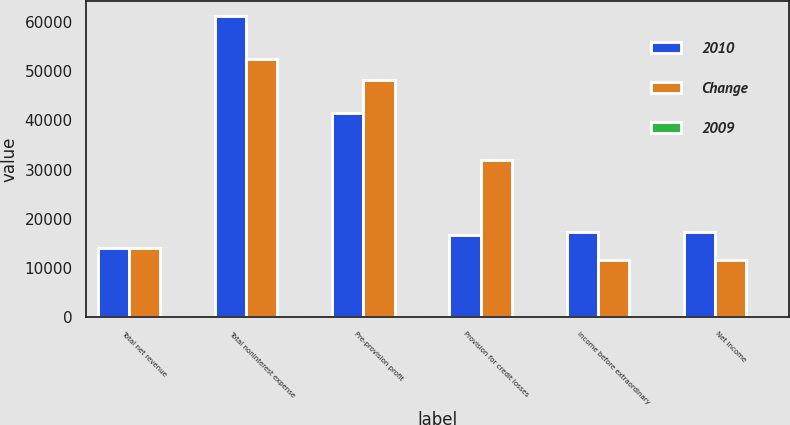Convert chart. <chart><loc_0><loc_0><loc_500><loc_500><stacked_bar_chart><ecel><fcel>Total net revenue<fcel>Total noninterest expense<fcel>Pre-provision profit<fcel>Provision for credit losses<fcel>Income before extraordinary<fcel>Net income<nl><fcel>2010<fcel>14183.5<fcel>61196<fcel>41498<fcel>16639<fcel>17370<fcel>17370<nl><fcel>Change<fcel>14183.5<fcel>52352<fcel>48082<fcel>32015<fcel>11652<fcel>11728<nl><fcel>2009<fcel>2<fcel>17<fcel>14<fcel>48<fcel>49<fcel>48<nl></chart> 